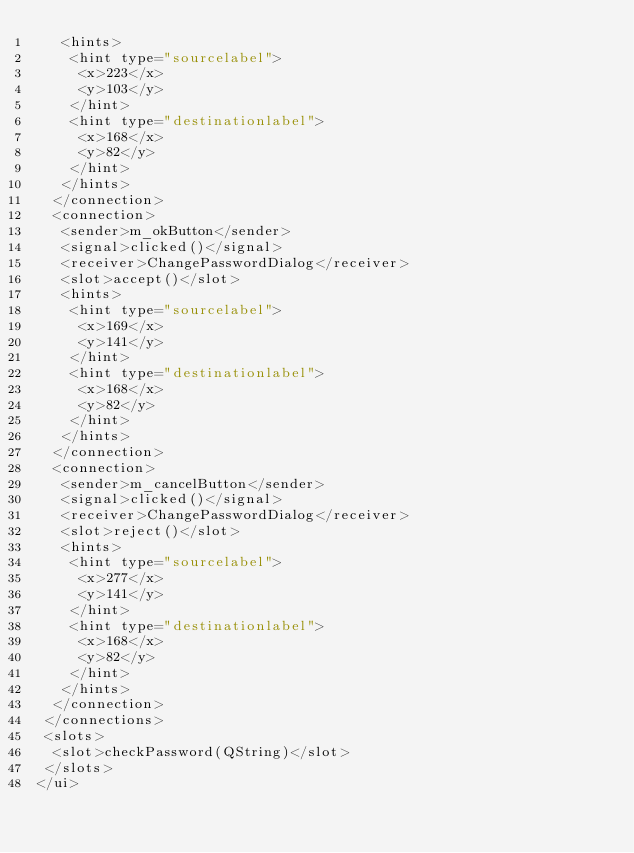<code> <loc_0><loc_0><loc_500><loc_500><_XML_>   <hints>
    <hint type="sourcelabel">
     <x>223</x>
     <y>103</y>
    </hint>
    <hint type="destinationlabel">
     <x>168</x>
     <y>82</y>
    </hint>
   </hints>
  </connection>
  <connection>
   <sender>m_okButton</sender>
   <signal>clicked()</signal>
   <receiver>ChangePasswordDialog</receiver>
   <slot>accept()</slot>
   <hints>
    <hint type="sourcelabel">
     <x>169</x>
     <y>141</y>
    </hint>
    <hint type="destinationlabel">
     <x>168</x>
     <y>82</y>
    </hint>
   </hints>
  </connection>
  <connection>
   <sender>m_cancelButton</sender>
   <signal>clicked()</signal>
   <receiver>ChangePasswordDialog</receiver>
   <slot>reject()</slot>
   <hints>
    <hint type="sourcelabel">
     <x>277</x>
     <y>141</y>
    </hint>
    <hint type="destinationlabel">
     <x>168</x>
     <y>82</y>
    </hint>
   </hints>
  </connection>
 </connections>
 <slots>
  <slot>checkPassword(QString)</slot>
 </slots>
</ui>
</code> 